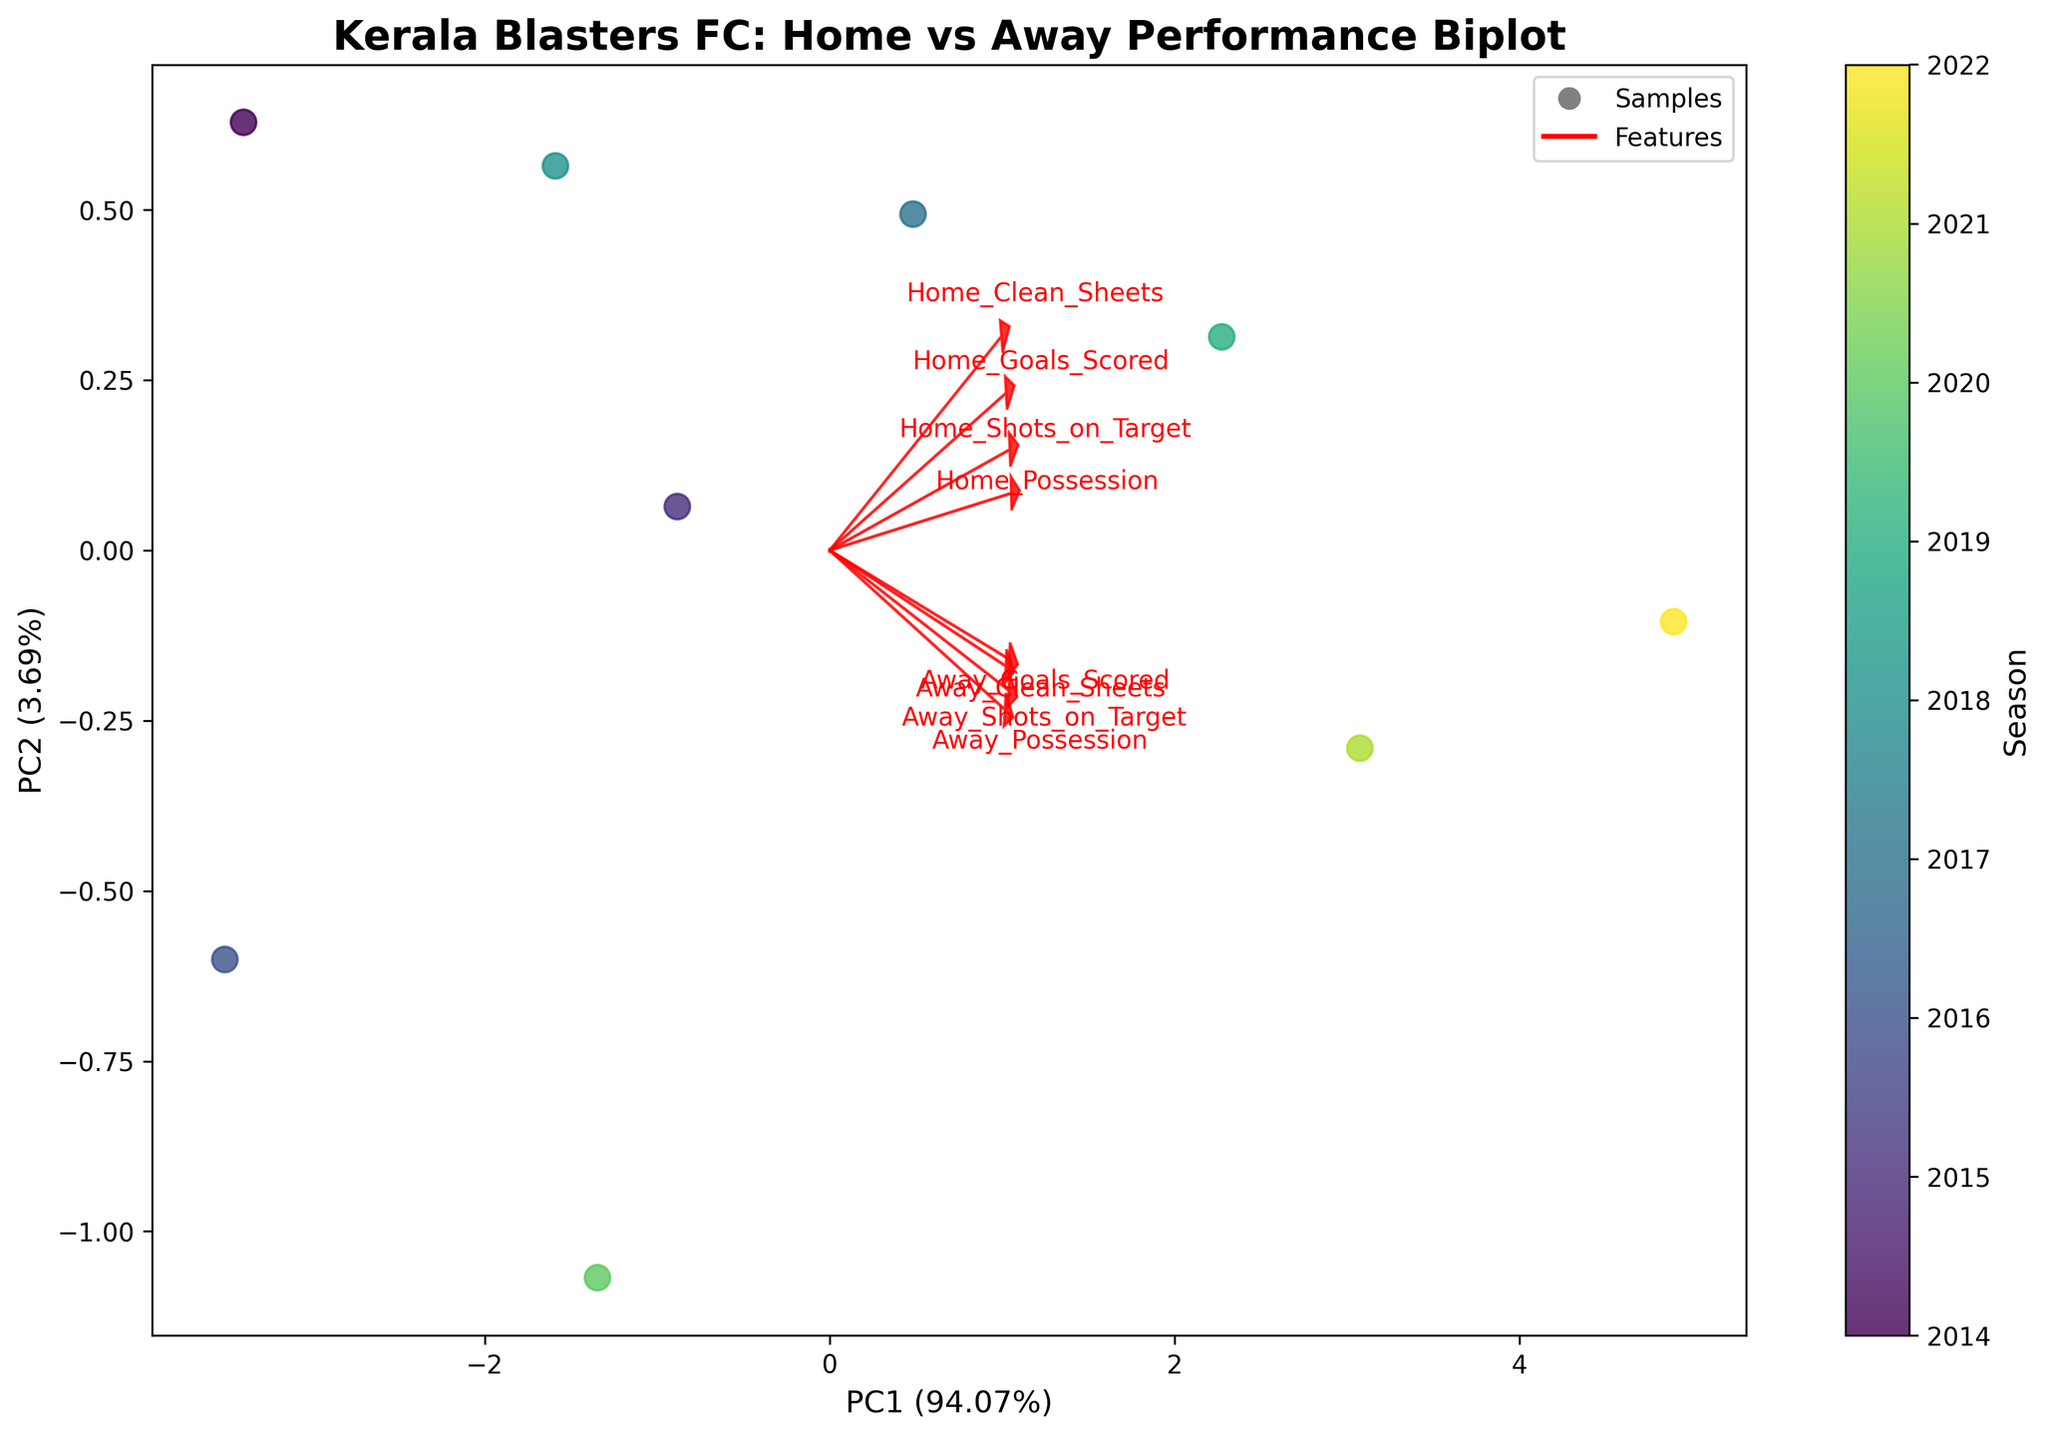How many Seasons are represented in the scatter plot? Count the number of distinct colors or points plotted on the X and Y axes.
Answer: 9 What is the title of the figure? Look at the text usually located at the top of the figure.
Answer: Kerala Blasters FC: Home vs Away Performance Biplot Which feature has the highest loading in the first Principal Component (PC1)? Observe the direction and length of the red arrows; the longer the arrow, the higher the loading. Specifically, compare the length of each arrow along the PC1 axis.
Answer: Home_Possession Between which years did Kerala Blasters FC's metrics vary the most in terms of PC1 and PC2? Check the distribution of points on the scatter plot. Identify the two points that are farthest apart.
Answer: Between 2014 and 2022 What do the red arrows indicate in the biplot? Arrows in a biplot typically represent the original variables projected into the principal component space.
Answer: The direction and magnitude of original variables (Home_Goals_Scored, Away_Goals_Scored, etc.) Which season had the highest combined Home and Away Goals Scored based on the scatter points? Add the Home_Goals_Scored and Away_Goals_Scored for each season and identify the highest sum by tracing it back to the corresponding scatter point on the plot.
Answer: 2022 How do Home and Away Possession correlate based on PC1 and PC2? Examine the direction and angle of the red arrows for Home_Possession and Away_Possession. If they point in a similar direction, they are positively correlated; if opposite, they are negatively correlated.
Answer: Positively correlated Which feature contributes most to PC2? Observe the red arrows' direction and length, focusing on their alignment with the PC2 axis. The feature with the most alignment and longest arrow indicates the highest contribution to PC2.
Answer: Home_Goals_Scored Is the variance explained by PC1 greater than PC2? Check the axis labels for PC1 and PC2, which typically include the percentage of explained variance. Compare these percentages.
Answer: Yes During which season did Kerala Blasters FC have the most clean sheets in totals? Sum the Home_Clean_Sheets and Away_Clean_Sheets for each season and identify the season with the highest total.
Answer: 2022 